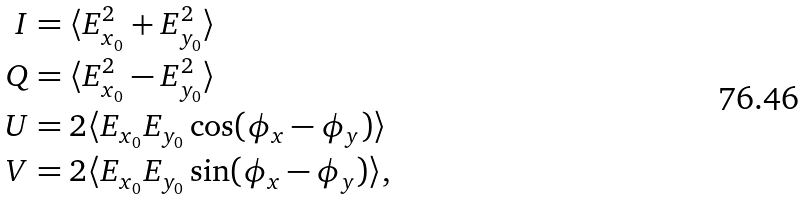Convert formula to latex. <formula><loc_0><loc_0><loc_500><loc_500>I & = \langle E _ { x _ { 0 } } ^ { 2 } + E _ { y _ { 0 } } ^ { 2 } \rangle \\ Q & = \langle E _ { x _ { 0 } } ^ { 2 } - E _ { y _ { 0 } } ^ { 2 } \rangle \\ U & = 2 \langle E _ { x _ { 0 } } E _ { y _ { 0 } } \cos ( \phi _ { x } - \phi _ { y } ) \rangle \\ V & = 2 \langle E _ { x _ { 0 } } E _ { y _ { 0 } } \sin ( \phi _ { x } - \phi _ { y } ) \rangle ,</formula> 